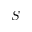<formula> <loc_0><loc_0><loc_500><loc_500>S</formula> 